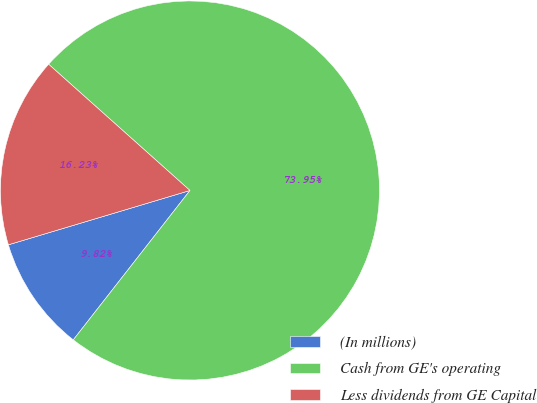Convert chart. <chart><loc_0><loc_0><loc_500><loc_500><pie_chart><fcel>(In millions)<fcel>Cash from GE's operating<fcel>Less dividends from GE Capital<nl><fcel>9.82%<fcel>73.95%<fcel>16.23%<nl></chart> 